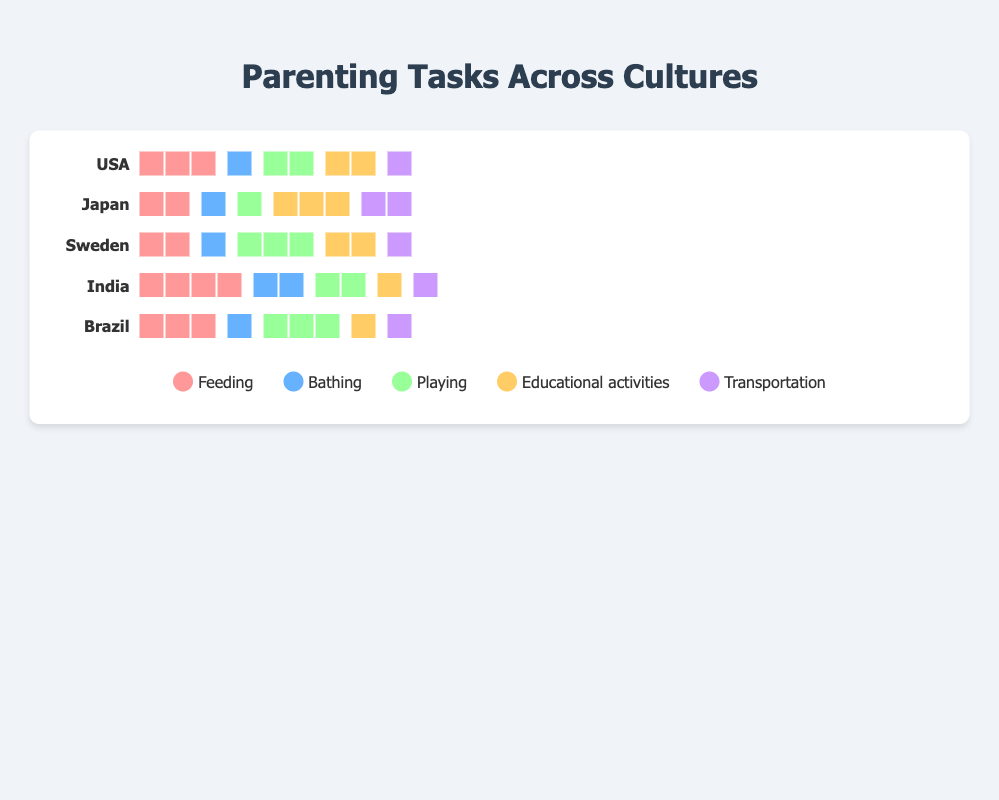What is the total time spent on 'Feeding' in Japan per day according to the plot? In the figure, each visual icon represents the time spent on various parenting tasks. According to the plot, there are 2 icons representing 'Feeding' time in Japan. Thus, the total time spent on 'Feeding' in Japan is 2 hours per day.
Answer: 2 hours Which parenting task requires the most time in India? By observing the number of icons for each task in India, 'Feeding' has the highest count with 4 icons, indicating that 'Feeding' requires the most time.
Answer: Feeding How many hours per day do parents in the USA spend on 'Educational activities' and 'Bathing' combined? From the plot, parents in the USA spend 2 hours on 'Educational activities' and 1 hour on 'Bathing'. Adding these together, the total is 2 + 1 = 3 hours.
Answer: 3 hours Which country allocates the least time for 'Playing' with children according to the plot? Each visual icon represents the time spent on various tasks. Observing the number of 'Playing' icons for each country, Japan has the least with only 1 icon.
Answer: Japan Compare the time spent on 'Transportation' in Brazil and Sweden. Which country allocates more time, and by how much? According to the plot, both Brazil and Sweden have the same number of icons (1) for 'Transportation'. Thus, they allocate the same amount of time.
Answer: They are equal Which parenting task shows the most variation in time spent across different countries? To determine variation, count the number of icons for each task across all countries. 'Feeding' varies from 2 to 4 icons, 'Bathing' varies from 1 to 2, 'Playing' varies from 1 to 3, 'Educational activities' varies from 1 to 3, and 'Transportation' is consistently 1 or 2. Thus, 'Playing' shows the most variation with a range from 1 to 3.
Answer: Playing What is the average time spent on 'Feeding' across all countries in the figure? Sum the number of icons for 'Feeding' across all countries (3 + 2 + 2 + 4 + 3 = 14), then divide by the number of countries (14 / 5 = 2.8). The average time is 2.8 hours per day.
Answer: 2.8 hours How much more time do parents in India spend on 'Feeding' compared to parents in Sweden? Parents in India spend 4 hours on 'Feeding' while parents in Sweden spend 2 hours. The difference is 4 - 2 = 2 hours.
Answer: 2 hours 